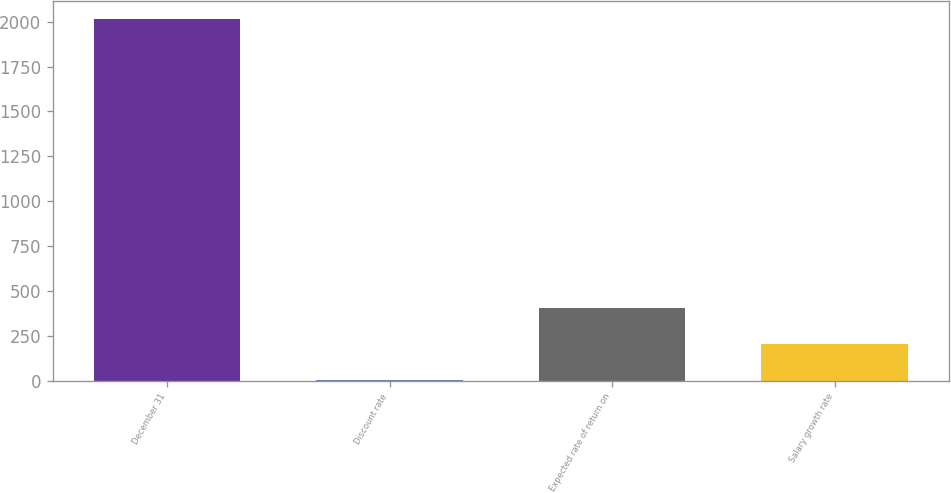<chart> <loc_0><loc_0><loc_500><loc_500><bar_chart><fcel>December 31<fcel>Discount rate<fcel>Expected rate of return on<fcel>Salary growth rate<nl><fcel>2015<fcel>2.7<fcel>405.16<fcel>203.93<nl></chart> 